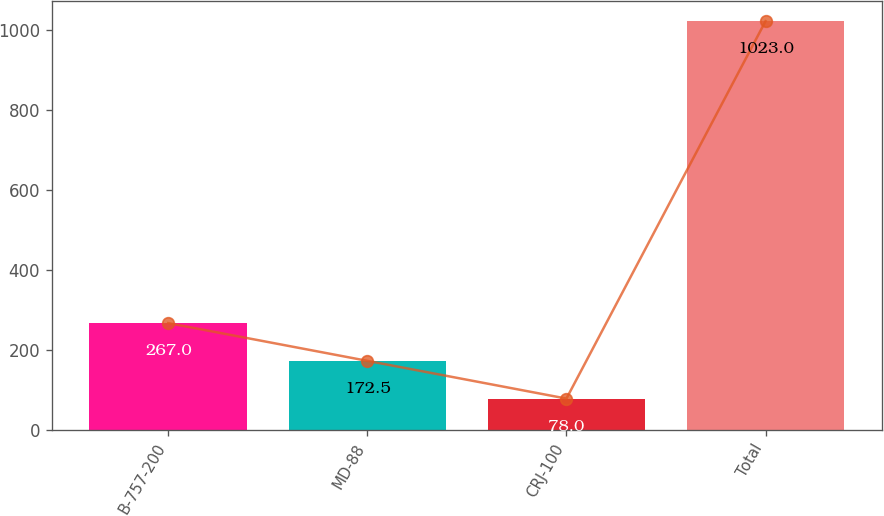Convert chart to OTSL. <chart><loc_0><loc_0><loc_500><loc_500><bar_chart><fcel>B-757-200<fcel>MD-88<fcel>CRJ-100<fcel>Total<nl><fcel>267<fcel>172.5<fcel>78<fcel>1023<nl></chart> 